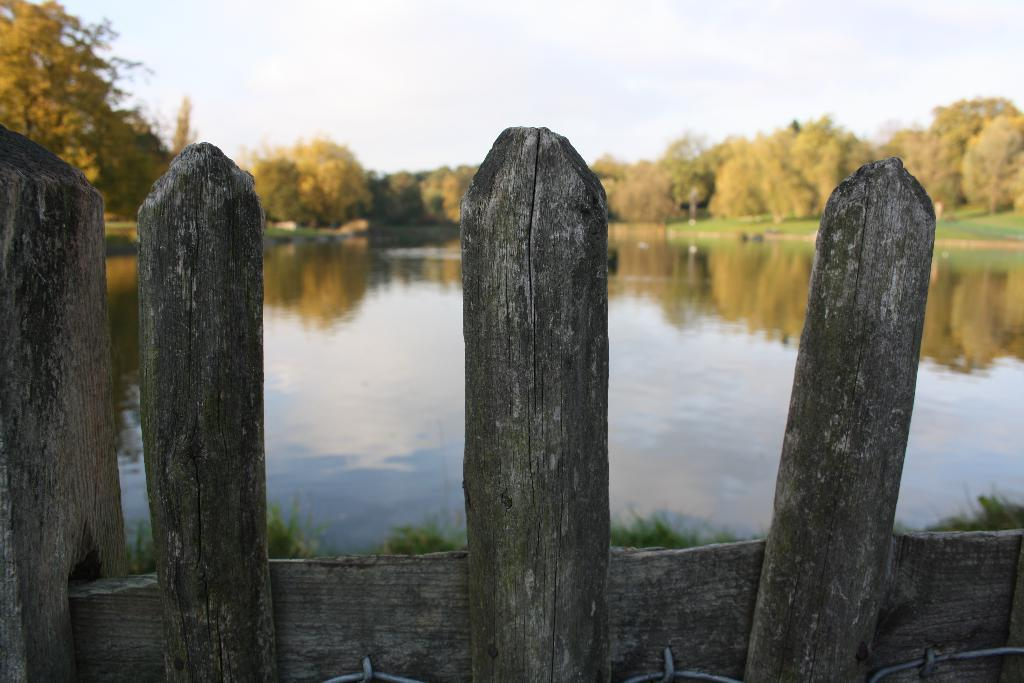What can be seen in the foreground of the picture? There is grass and railing in the foreground of the picture. What is the main feature in the center of the picture? There is a water body in the center of the picture. What type of vegetation is visible in the background of the picture? There are trees and grass in the background of the picture. How would you describe the weather in the image? The sky is sunny in the image. What type of reward is being given to the dirt in the image? There is no dirt present in the image, and therefore no reward can be given to it. How does the caretaker maintain the trees in the image? The image does not show any caretaker or maintenance activity, so it is not possible to answer this question. 